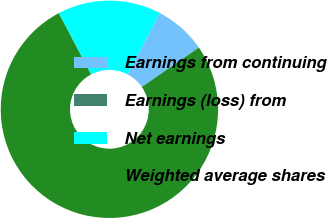Convert chart. <chart><loc_0><loc_0><loc_500><loc_500><pie_chart><fcel>Earnings from continuing<fcel>Earnings (loss) from<fcel>Net earnings<fcel>Weighted average shares<nl><fcel>7.7%<fcel>0.02%<fcel>15.39%<fcel>76.89%<nl></chart> 